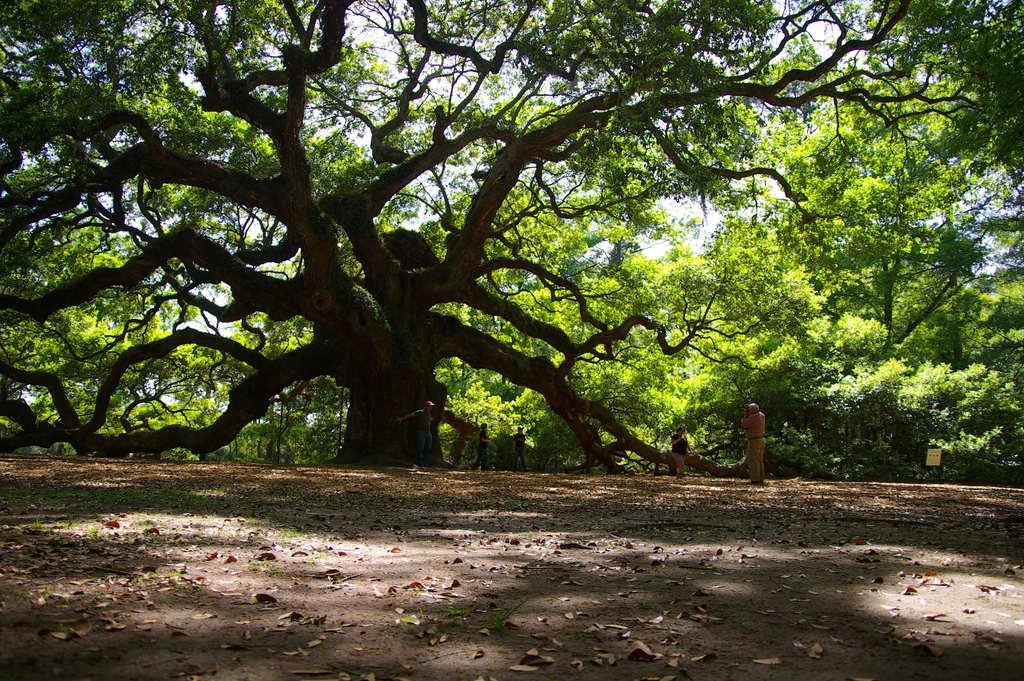In one or two sentences, can you explain what this image depicts? In this image I can see the ground, few leaves on the ground, few persons standing on the ground and a huge tree which is black and green in color. In the background I can see the sky. 